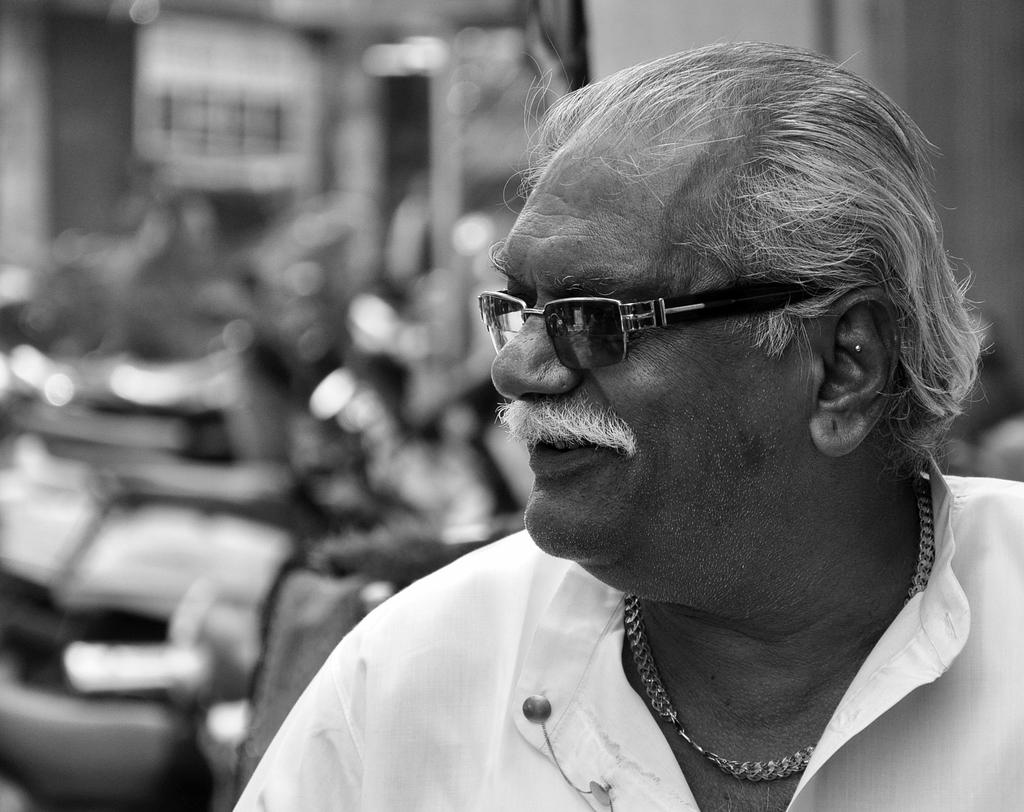What is the color scheme of the image? The image is black and white. Can you describe the person in the image? There is a person in the image, and they are wearing a white shirt. What accessory is the person wearing in the image? The person is wearing spectacles in the image. What type of glue can be seen on the person's shirt in the image? There is no glue present on the person's shirt in the image. Is the person in the image trying to escape from quicksand? There is no quicksand present in the image, and the person is not depicted in any such situation. 